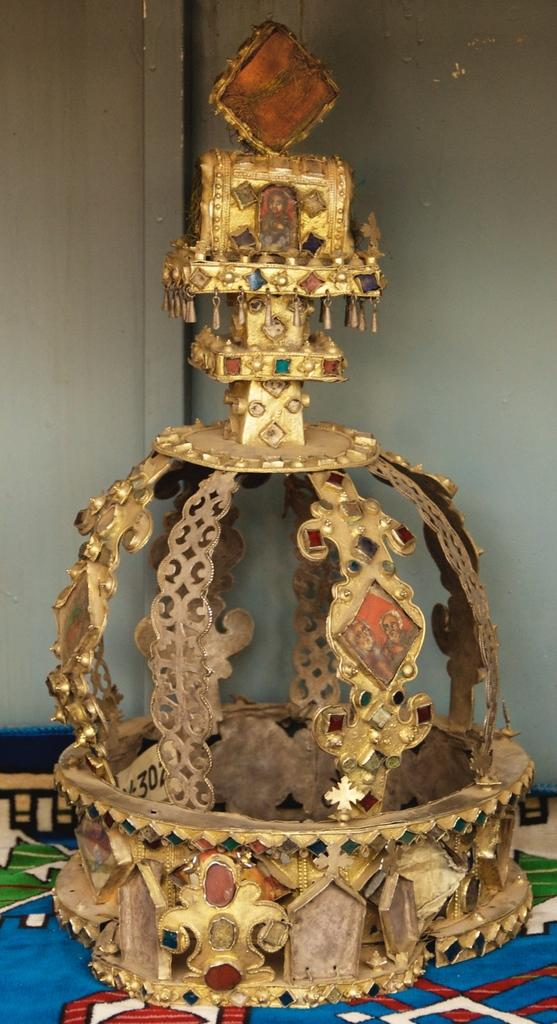What is the main object in the image? There is a crown in the image. Where is the crown located? The crown is placed on a carpet. What type of creature is holding the apple on the carpet in the image? There is no creature or apple present in the image; it only features a crown placed on a carpet. 